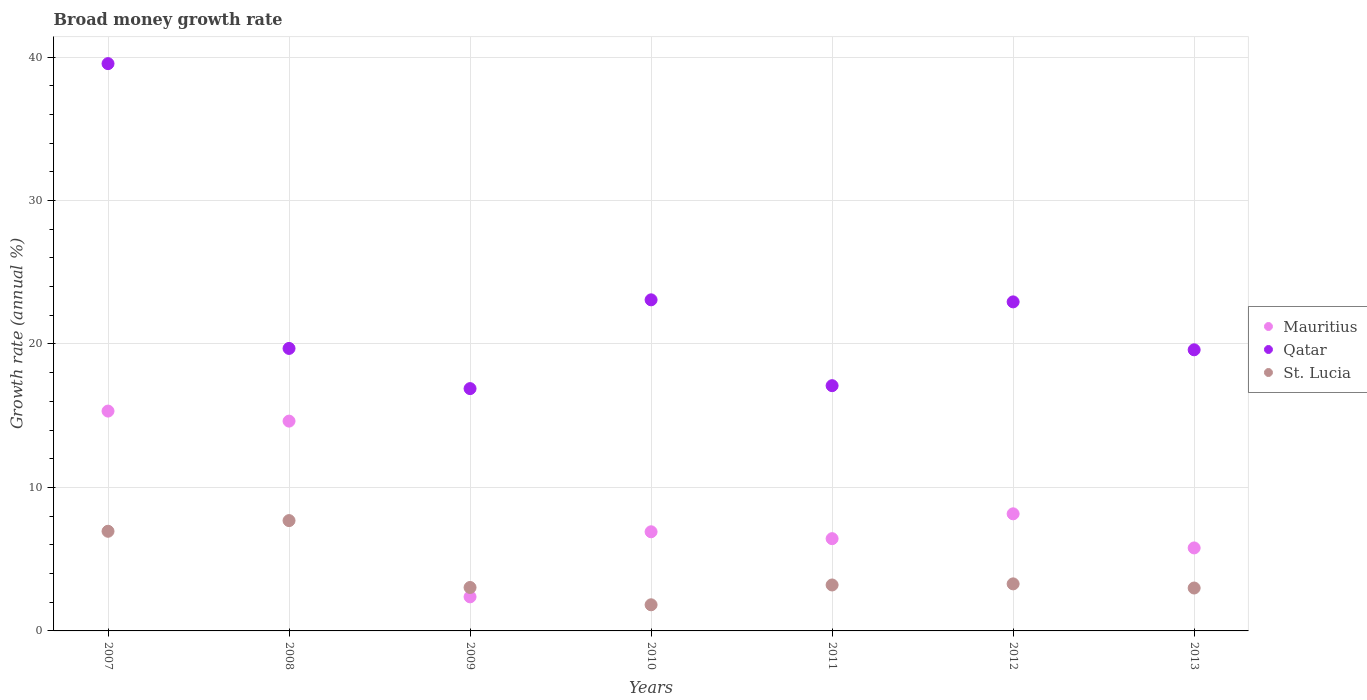What is the growth rate in Qatar in 2007?
Provide a short and direct response. 39.54. Across all years, what is the maximum growth rate in St. Lucia?
Offer a very short reply. 7.69. Across all years, what is the minimum growth rate in St. Lucia?
Your answer should be compact. 1.82. What is the total growth rate in St. Lucia in the graph?
Make the answer very short. 28.96. What is the difference between the growth rate in St. Lucia in 2009 and that in 2013?
Provide a short and direct response. 0.04. What is the difference between the growth rate in Mauritius in 2008 and the growth rate in Qatar in 2010?
Offer a terse response. -8.45. What is the average growth rate in Qatar per year?
Make the answer very short. 22.69. In the year 2010, what is the difference between the growth rate in St. Lucia and growth rate in Qatar?
Keep it short and to the point. -21.26. What is the ratio of the growth rate in Qatar in 2009 to that in 2010?
Your response must be concise. 0.73. Is the growth rate in St. Lucia in 2011 less than that in 2012?
Provide a succinct answer. Yes. Is the difference between the growth rate in St. Lucia in 2008 and 2013 greater than the difference between the growth rate in Qatar in 2008 and 2013?
Make the answer very short. Yes. What is the difference between the highest and the second highest growth rate in Qatar?
Give a very brief answer. 16.46. What is the difference between the highest and the lowest growth rate in Mauritius?
Offer a terse response. 12.95. In how many years, is the growth rate in Mauritius greater than the average growth rate in Mauritius taken over all years?
Your response must be concise. 2. Is the sum of the growth rate in Qatar in 2011 and 2012 greater than the maximum growth rate in St. Lucia across all years?
Provide a short and direct response. Yes. Is the growth rate in Qatar strictly greater than the growth rate in Mauritius over the years?
Offer a very short reply. Yes. Is the growth rate in St. Lucia strictly less than the growth rate in Qatar over the years?
Make the answer very short. Yes. How many dotlines are there?
Provide a succinct answer. 3. Are the values on the major ticks of Y-axis written in scientific E-notation?
Make the answer very short. No. Does the graph contain grids?
Your answer should be compact. Yes. Where does the legend appear in the graph?
Offer a terse response. Center right. What is the title of the graph?
Offer a terse response. Broad money growth rate. Does "Uzbekistan" appear as one of the legend labels in the graph?
Ensure brevity in your answer.  No. What is the label or title of the Y-axis?
Offer a very short reply. Growth rate (annual %). What is the Growth rate (annual %) of Mauritius in 2007?
Ensure brevity in your answer.  15.32. What is the Growth rate (annual %) in Qatar in 2007?
Provide a succinct answer. 39.54. What is the Growth rate (annual %) in St. Lucia in 2007?
Your answer should be very brief. 6.95. What is the Growth rate (annual %) of Mauritius in 2008?
Your answer should be compact. 14.62. What is the Growth rate (annual %) of Qatar in 2008?
Keep it short and to the point. 19.69. What is the Growth rate (annual %) in St. Lucia in 2008?
Make the answer very short. 7.69. What is the Growth rate (annual %) of Mauritius in 2009?
Keep it short and to the point. 2.37. What is the Growth rate (annual %) in Qatar in 2009?
Your answer should be compact. 16.89. What is the Growth rate (annual %) in St. Lucia in 2009?
Your answer should be very brief. 3.03. What is the Growth rate (annual %) of Mauritius in 2010?
Give a very brief answer. 6.91. What is the Growth rate (annual %) in Qatar in 2010?
Your answer should be very brief. 23.08. What is the Growth rate (annual %) in St. Lucia in 2010?
Give a very brief answer. 1.82. What is the Growth rate (annual %) in Mauritius in 2011?
Provide a succinct answer. 6.43. What is the Growth rate (annual %) of Qatar in 2011?
Your answer should be compact. 17.09. What is the Growth rate (annual %) of St. Lucia in 2011?
Ensure brevity in your answer.  3.2. What is the Growth rate (annual %) of Mauritius in 2012?
Your response must be concise. 8.16. What is the Growth rate (annual %) in Qatar in 2012?
Your answer should be compact. 22.93. What is the Growth rate (annual %) of St. Lucia in 2012?
Keep it short and to the point. 3.28. What is the Growth rate (annual %) in Mauritius in 2013?
Provide a succinct answer. 5.78. What is the Growth rate (annual %) of Qatar in 2013?
Provide a succinct answer. 19.59. What is the Growth rate (annual %) in St. Lucia in 2013?
Ensure brevity in your answer.  2.99. Across all years, what is the maximum Growth rate (annual %) of Mauritius?
Ensure brevity in your answer.  15.32. Across all years, what is the maximum Growth rate (annual %) in Qatar?
Keep it short and to the point. 39.54. Across all years, what is the maximum Growth rate (annual %) of St. Lucia?
Your answer should be very brief. 7.69. Across all years, what is the minimum Growth rate (annual %) in Mauritius?
Offer a very short reply. 2.37. Across all years, what is the minimum Growth rate (annual %) in Qatar?
Your answer should be compact. 16.89. Across all years, what is the minimum Growth rate (annual %) in St. Lucia?
Offer a very short reply. 1.82. What is the total Growth rate (annual %) in Mauritius in the graph?
Provide a succinct answer. 59.61. What is the total Growth rate (annual %) of Qatar in the graph?
Provide a succinct answer. 158.82. What is the total Growth rate (annual %) in St. Lucia in the graph?
Your answer should be compact. 28.96. What is the difference between the Growth rate (annual %) of Mauritius in 2007 and that in 2008?
Offer a terse response. 0.7. What is the difference between the Growth rate (annual %) of Qatar in 2007 and that in 2008?
Keep it short and to the point. 19.85. What is the difference between the Growth rate (annual %) of St. Lucia in 2007 and that in 2008?
Offer a terse response. -0.74. What is the difference between the Growth rate (annual %) in Mauritius in 2007 and that in 2009?
Make the answer very short. 12.95. What is the difference between the Growth rate (annual %) in Qatar in 2007 and that in 2009?
Your response must be concise. 22.65. What is the difference between the Growth rate (annual %) of St. Lucia in 2007 and that in 2009?
Provide a short and direct response. 3.92. What is the difference between the Growth rate (annual %) in Mauritius in 2007 and that in 2010?
Ensure brevity in your answer.  8.41. What is the difference between the Growth rate (annual %) in Qatar in 2007 and that in 2010?
Your answer should be compact. 16.46. What is the difference between the Growth rate (annual %) in St. Lucia in 2007 and that in 2010?
Make the answer very short. 5.12. What is the difference between the Growth rate (annual %) of Mauritius in 2007 and that in 2011?
Your response must be concise. 8.89. What is the difference between the Growth rate (annual %) in Qatar in 2007 and that in 2011?
Your response must be concise. 22.45. What is the difference between the Growth rate (annual %) of St. Lucia in 2007 and that in 2011?
Your response must be concise. 3.74. What is the difference between the Growth rate (annual %) in Mauritius in 2007 and that in 2012?
Provide a short and direct response. 7.16. What is the difference between the Growth rate (annual %) of Qatar in 2007 and that in 2012?
Offer a terse response. 16.61. What is the difference between the Growth rate (annual %) of St. Lucia in 2007 and that in 2012?
Give a very brief answer. 3.67. What is the difference between the Growth rate (annual %) of Mauritius in 2007 and that in 2013?
Offer a terse response. 9.54. What is the difference between the Growth rate (annual %) in Qatar in 2007 and that in 2013?
Make the answer very short. 19.95. What is the difference between the Growth rate (annual %) in St. Lucia in 2007 and that in 2013?
Keep it short and to the point. 3.95. What is the difference between the Growth rate (annual %) of Mauritius in 2008 and that in 2009?
Your response must be concise. 12.25. What is the difference between the Growth rate (annual %) of Qatar in 2008 and that in 2009?
Keep it short and to the point. 2.8. What is the difference between the Growth rate (annual %) in St. Lucia in 2008 and that in 2009?
Your response must be concise. 4.66. What is the difference between the Growth rate (annual %) in Mauritius in 2008 and that in 2010?
Your response must be concise. 7.71. What is the difference between the Growth rate (annual %) in Qatar in 2008 and that in 2010?
Offer a very short reply. -3.39. What is the difference between the Growth rate (annual %) in St. Lucia in 2008 and that in 2010?
Provide a short and direct response. 5.87. What is the difference between the Growth rate (annual %) in Mauritius in 2008 and that in 2011?
Provide a short and direct response. 8.19. What is the difference between the Growth rate (annual %) in Qatar in 2008 and that in 2011?
Offer a very short reply. 2.6. What is the difference between the Growth rate (annual %) of St. Lucia in 2008 and that in 2011?
Your answer should be very brief. 4.49. What is the difference between the Growth rate (annual %) of Mauritius in 2008 and that in 2012?
Provide a succinct answer. 6.46. What is the difference between the Growth rate (annual %) of Qatar in 2008 and that in 2012?
Offer a terse response. -3.24. What is the difference between the Growth rate (annual %) of St. Lucia in 2008 and that in 2012?
Ensure brevity in your answer.  4.41. What is the difference between the Growth rate (annual %) in Mauritius in 2008 and that in 2013?
Keep it short and to the point. 8.84. What is the difference between the Growth rate (annual %) of Qatar in 2008 and that in 2013?
Keep it short and to the point. 0.1. What is the difference between the Growth rate (annual %) of St. Lucia in 2008 and that in 2013?
Provide a succinct answer. 4.7. What is the difference between the Growth rate (annual %) in Mauritius in 2009 and that in 2010?
Your answer should be compact. -4.54. What is the difference between the Growth rate (annual %) in Qatar in 2009 and that in 2010?
Your answer should be compact. -6.19. What is the difference between the Growth rate (annual %) of St. Lucia in 2009 and that in 2010?
Provide a succinct answer. 1.21. What is the difference between the Growth rate (annual %) of Mauritius in 2009 and that in 2011?
Make the answer very short. -4.06. What is the difference between the Growth rate (annual %) of Qatar in 2009 and that in 2011?
Keep it short and to the point. -0.2. What is the difference between the Growth rate (annual %) in St. Lucia in 2009 and that in 2011?
Your answer should be compact. -0.17. What is the difference between the Growth rate (annual %) in Mauritius in 2009 and that in 2012?
Provide a short and direct response. -5.79. What is the difference between the Growth rate (annual %) in Qatar in 2009 and that in 2012?
Your response must be concise. -6.04. What is the difference between the Growth rate (annual %) in St. Lucia in 2009 and that in 2012?
Offer a very short reply. -0.25. What is the difference between the Growth rate (annual %) of Mauritius in 2009 and that in 2013?
Your response must be concise. -3.41. What is the difference between the Growth rate (annual %) in Qatar in 2009 and that in 2013?
Provide a succinct answer. -2.7. What is the difference between the Growth rate (annual %) of St. Lucia in 2009 and that in 2013?
Provide a succinct answer. 0.04. What is the difference between the Growth rate (annual %) in Mauritius in 2010 and that in 2011?
Make the answer very short. 0.48. What is the difference between the Growth rate (annual %) of Qatar in 2010 and that in 2011?
Offer a very short reply. 5.98. What is the difference between the Growth rate (annual %) of St. Lucia in 2010 and that in 2011?
Provide a succinct answer. -1.38. What is the difference between the Growth rate (annual %) in Mauritius in 2010 and that in 2012?
Your answer should be very brief. -1.25. What is the difference between the Growth rate (annual %) in Qatar in 2010 and that in 2012?
Your response must be concise. 0.14. What is the difference between the Growth rate (annual %) in St. Lucia in 2010 and that in 2012?
Offer a terse response. -1.46. What is the difference between the Growth rate (annual %) of Mauritius in 2010 and that in 2013?
Provide a succinct answer. 1.13. What is the difference between the Growth rate (annual %) of Qatar in 2010 and that in 2013?
Ensure brevity in your answer.  3.48. What is the difference between the Growth rate (annual %) in St. Lucia in 2010 and that in 2013?
Provide a succinct answer. -1.17. What is the difference between the Growth rate (annual %) of Mauritius in 2011 and that in 2012?
Your response must be concise. -1.73. What is the difference between the Growth rate (annual %) of Qatar in 2011 and that in 2012?
Keep it short and to the point. -5.84. What is the difference between the Growth rate (annual %) of St. Lucia in 2011 and that in 2012?
Your answer should be very brief. -0.08. What is the difference between the Growth rate (annual %) of Mauritius in 2011 and that in 2013?
Give a very brief answer. 0.65. What is the difference between the Growth rate (annual %) in Qatar in 2011 and that in 2013?
Provide a succinct answer. -2.5. What is the difference between the Growth rate (annual %) in St. Lucia in 2011 and that in 2013?
Your response must be concise. 0.21. What is the difference between the Growth rate (annual %) in Mauritius in 2012 and that in 2013?
Keep it short and to the point. 2.38. What is the difference between the Growth rate (annual %) of Qatar in 2012 and that in 2013?
Keep it short and to the point. 3.34. What is the difference between the Growth rate (annual %) in St. Lucia in 2012 and that in 2013?
Make the answer very short. 0.29. What is the difference between the Growth rate (annual %) of Mauritius in 2007 and the Growth rate (annual %) of Qatar in 2008?
Your response must be concise. -4.37. What is the difference between the Growth rate (annual %) in Mauritius in 2007 and the Growth rate (annual %) in St. Lucia in 2008?
Provide a short and direct response. 7.63. What is the difference between the Growth rate (annual %) in Qatar in 2007 and the Growth rate (annual %) in St. Lucia in 2008?
Your response must be concise. 31.85. What is the difference between the Growth rate (annual %) in Mauritius in 2007 and the Growth rate (annual %) in Qatar in 2009?
Give a very brief answer. -1.57. What is the difference between the Growth rate (annual %) of Mauritius in 2007 and the Growth rate (annual %) of St. Lucia in 2009?
Provide a short and direct response. 12.29. What is the difference between the Growth rate (annual %) of Qatar in 2007 and the Growth rate (annual %) of St. Lucia in 2009?
Make the answer very short. 36.51. What is the difference between the Growth rate (annual %) of Mauritius in 2007 and the Growth rate (annual %) of Qatar in 2010?
Your response must be concise. -7.75. What is the difference between the Growth rate (annual %) in Mauritius in 2007 and the Growth rate (annual %) in St. Lucia in 2010?
Your answer should be compact. 13.5. What is the difference between the Growth rate (annual %) of Qatar in 2007 and the Growth rate (annual %) of St. Lucia in 2010?
Make the answer very short. 37.72. What is the difference between the Growth rate (annual %) in Mauritius in 2007 and the Growth rate (annual %) in Qatar in 2011?
Keep it short and to the point. -1.77. What is the difference between the Growth rate (annual %) in Mauritius in 2007 and the Growth rate (annual %) in St. Lucia in 2011?
Offer a very short reply. 12.12. What is the difference between the Growth rate (annual %) in Qatar in 2007 and the Growth rate (annual %) in St. Lucia in 2011?
Offer a terse response. 36.34. What is the difference between the Growth rate (annual %) in Mauritius in 2007 and the Growth rate (annual %) in Qatar in 2012?
Give a very brief answer. -7.61. What is the difference between the Growth rate (annual %) of Mauritius in 2007 and the Growth rate (annual %) of St. Lucia in 2012?
Your answer should be very brief. 12.04. What is the difference between the Growth rate (annual %) of Qatar in 2007 and the Growth rate (annual %) of St. Lucia in 2012?
Give a very brief answer. 36.26. What is the difference between the Growth rate (annual %) of Mauritius in 2007 and the Growth rate (annual %) of Qatar in 2013?
Offer a terse response. -4.27. What is the difference between the Growth rate (annual %) in Mauritius in 2007 and the Growth rate (annual %) in St. Lucia in 2013?
Provide a short and direct response. 12.33. What is the difference between the Growth rate (annual %) of Qatar in 2007 and the Growth rate (annual %) of St. Lucia in 2013?
Your response must be concise. 36.55. What is the difference between the Growth rate (annual %) in Mauritius in 2008 and the Growth rate (annual %) in Qatar in 2009?
Give a very brief answer. -2.27. What is the difference between the Growth rate (annual %) in Mauritius in 2008 and the Growth rate (annual %) in St. Lucia in 2009?
Provide a succinct answer. 11.6. What is the difference between the Growth rate (annual %) of Qatar in 2008 and the Growth rate (annual %) of St. Lucia in 2009?
Provide a succinct answer. 16.66. What is the difference between the Growth rate (annual %) in Mauritius in 2008 and the Growth rate (annual %) in Qatar in 2010?
Offer a very short reply. -8.45. What is the difference between the Growth rate (annual %) in Mauritius in 2008 and the Growth rate (annual %) in St. Lucia in 2010?
Ensure brevity in your answer.  12.8. What is the difference between the Growth rate (annual %) in Qatar in 2008 and the Growth rate (annual %) in St. Lucia in 2010?
Offer a terse response. 17.87. What is the difference between the Growth rate (annual %) of Mauritius in 2008 and the Growth rate (annual %) of Qatar in 2011?
Give a very brief answer. -2.47. What is the difference between the Growth rate (annual %) in Mauritius in 2008 and the Growth rate (annual %) in St. Lucia in 2011?
Provide a succinct answer. 11.42. What is the difference between the Growth rate (annual %) in Qatar in 2008 and the Growth rate (annual %) in St. Lucia in 2011?
Offer a terse response. 16.49. What is the difference between the Growth rate (annual %) of Mauritius in 2008 and the Growth rate (annual %) of Qatar in 2012?
Provide a succinct answer. -8.31. What is the difference between the Growth rate (annual %) of Mauritius in 2008 and the Growth rate (annual %) of St. Lucia in 2012?
Your answer should be compact. 11.34. What is the difference between the Growth rate (annual %) of Qatar in 2008 and the Growth rate (annual %) of St. Lucia in 2012?
Your response must be concise. 16.41. What is the difference between the Growth rate (annual %) in Mauritius in 2008 and the Growth rate (annual %) in Qatar in 2013?
Your answer should be compact. -4.97. What is the difference between the Growth rate (annual %) of Mauritius in 2008 and the Growth rate (annual %) of St. Lucia in 2013?
Offer a terse response. 11.63. What is the difference between the Growth rate (annual %) in Qatar in 2008 and the Growth rate (annual %) in St. Lucia in 2013?
Your response must be concise. 16.7. What is the difference between the Growth rate (annual %) of Mauritius in 2009 and the Growth rate (annual %) of Qatar in 2010?
Offer a terse response. -20.7. What is the difference between the Growth rate (annual %) in Mauritius in 2009 and the Growth rate (annual %) in St. Lucia in 2010?
Offer a terse response. 0.55. What is the difference between the Growth rate (annual %) of Qatar in 2009 and the Growth rate (annual %) of St. Lucia in 2010?
Make the answer very short. 15.07. What is the difference between the Growth rate (annual %) in Mauritius in 2009 and the Growth rate (annual %) in Qatar in 2011?
Make the answer very short. -14.72. What is the difference between the Growth rate (annual %) of Mauritius in 2009 and the Growth rate (annual %) of St. Lucia in 2011?
Ensure brevity in your answer.  -0.83. What is the difference between the Growth rate (annual %) in Qatar in 2009 and the Growth rate (annual %) in St. Lucia in 2011?
Offer a terse response. 13.69. What is the difference between the Growth rate (annual %) of Mauritius in 2009 and the Growth rate (annual %) of Qatar in 2012?
Your answer should be compact. -20.56. What is the difference between the Growth rate (annual %) of Mauritius in 2009 and the Growth rate (annual %) of St. Lucia in 2012?
Give a very brief answer. -0.91. What is the difference between the Growth rate (annual %) in Qatar in 2009 and the Growth rate (annual %) in St. Lucia in 2012?
Ensure brevity in your answer.  13.61. What is the difference between the Growth rate (annual %) of Mauritius in 2009 and the Growth rate (annual %) of Qatar in 2013?
Provide a succinct answer. -17.22. What is the difference between the Growth rate (annual %) of Mauritius in 2009 and the Growth rate (annual %) of St. Lucia in 2013?
Your answer should be compact. -0.62. What is the difference between the Growth rate (annual %) in Qatar in 2009 and the Growth rate (annual %) in St. Lucia in 2013?
Offer a very short reply. 13.9. What is the difference between the Growth rate (annual %) of Mauritius in 2010 and the Growth rate (annual %) of Qatar in 2011?
Your answer should be compact. -10.18. What is the difference between the Growth rate (annual %) in Mauritius in 2010 and the Growth rate (annual %) in St. Lucia in 2011?
Your answer should be compact. 3.71. What is the difference between the Growth rate (annual %) in Qatar in 2010 and the Growth rate (annual %) in St. Lucia in 2011?
Your response must be concise. 19.87. What is the difference between the Growth rate (annual %) in Mauritius in 2010 and the Growth rate (annual %) in Qatar in 2012?
Provide a short and direct response. -16.02. What is the difference between the Growth rate (annual %) in Mauritius in 2010 and the Growth rate (annual %) in St. Lucia in 2012?
Provide a short and direct response. 3.63. What is the difference between the Growth rate (annual %) in Qatar in 2010 and the Growth rate (annual %) in St. Lucia in 2012?
Offer a very short reply. 19.8. What is the difference between the Growth rate (annual %) in Mauritius in 2010 and the Growth rate (annual %) in Qatar in 2013?
Keep it short and to the point. -12.68. What is the difference between the Growth rate (annual %) of Mauritius in 2010 and the Growth rate (annual %) of St. Lucia in 2013?
Your answer should be compact. 3.92. What is the difference between the Growth rate (annual %) in Qatar in 2010 and the Growth rate (annual %) in St. Lucia in 2013?
Give a very brief answer. 20.09. What is the difference between the Growth rate (annual %) of Mauritius in 2011 and the Growth rate (annual %) of Qatar in 2012?
Provide a short and direct response. -16.5. What is the difference between the Growth rate (annual %) in Mauritius in 2011 and the Growth rate (annual %) in St. Lucia in 2012?
Make the answer very short. 3.15. What is the difference between the Growth rate (annual %) of Qatar in 2011 and the Growth rate (annual %) of St. Lucia in 2012?
Offer a very short reply. 13.81. What is the difference between the Growth rate (annual %) of Mauritius in 2011 and the Growth rate (annual %) of Qatar in 2013?
Provide a succinct answer. -13.16. What is the difference between the Growth rate (annual %) of Mauritius in 2011 and the Growth rate (annual %) of St. Lucia in 2013?
Your answer should be compact. 3.44. What is the difference between the Growth rate (annual %) of Qatar in 2011 and the Growth rate (annual %) of St. Lucia in 2013?
Make the answer very short. 14.1. What is the difference between the Growth rate (annual %) in Mauritius in 2012 and the Growth rate (annual %) in Qatar in 2013?
Ensure brevity in your answer.  -11.43. What is the difference between the Growth rate (annual %) in Mauritius in 2012 and the Growth rate (annual %) in St. Lucia in 2013?
Your answer should be very brief. 5.17. What is the difference between the Growth rate (annual %) of Qatar in 2012 and the Growth rate (annual %) of St. Lucia in 2013?
Your answer should be very brief. 19.94. What is the average Growth rate (annual %) of Mauritius per year?
Provide a succinct answer. 8.52. What is the average Growth rate (annual %) of Qatar per year?
Make the answer very short. 22.69. What is the average Growth rate (annual %) of St. Lucia per year?
Your answer should be compact. 4.14. In the year 2007, what is the difference between the Growth rate (annual %) of Mauritius and Growth rate (annual %) of Qatar?
Offer a very short reply. -24.22. In the year 2007, what is the difference between the Growth rate (annual %) in Mauritius and Growth rate (annual %) in St. Lucia?
Keep it short and to the point. 8.38. In the year 2007, what is the difference between the Growth rate (annual %) in Qatar and Growth rate (annual %) in St. Lucia?
Your response must be concise. 32.59. In the year 2008, what is the difference between the Growth rate (annual %) in Mauritius and Growth rate (annual %) in Qatar?
Give a very brief answer. -5.07. In the year 2008, what is the difference between the Growth rate (annual %) of Mauritius and Growth rate (annual %) of St. Lucia?
Your answer should be very brief. 6.93. In the year 2008, what is the difference between the Growth rate (annual %) in Qatar and Growth rate (annual %) in St. Lucia?
Your answer should be compact. 12. In the year 2009, what is the difference between the Growth rate (annual %) in Mauritius and Growth rate (annual %) in Qatar?
Your answer should be very brief. -14.51. In the year 2009, what is the difference between the Growth rate (annual %) in Mauritius and Growth rate (annual %) in St. Lucia?
Make the answer very short. -0.65. In the year 2009, what is the difference between the Growth rate (annual %) in Qatar and Growth rate (annual %) in St. Lucia?
Make the answer very short. 13.86. In the year 2010, what is the difference between the Growth rate (annual %) of Mauritius and Growth rate (annual %) of Qatar?
Offer a very short reply. -16.17. In the year 2010, what is the difference between the Growth rate (annual %) of Mauritius and Growth rate (annual %) of St. Lucia?
Ensure brevity in your answer.  5.09. In the year 2010, what is the difference between the Growth rate (annual %) of Qatar and Growth rate (annual %) of St. Lucia?
Ensure brevity in your answer.  21.26. In the year 2011, what is the difference between the Growth rate (annual %) of Mauritius and Growth rate (annual %) of Qatar?
Offer a terse response. -10.66. In the year 2011, what is the difference between the Growth rate (annual %) in Mauritius and Growth rate (annual %) in St. Lucia?
Give a very brief answer. 3.23. In the year 2011, what is the difference between the Growth rate (annual %) of Qatar and Growth rate (annual %) of St. Lucia?
Offer a very short reply. 13.89. In the year 2012, what is the difference between the Growth rate (annual %) of Mauritius and Growth rate (annual %) of Qatar?
Ensure brevity in your answer.  -14.77. In the year 2012, what is the difference between the Growth rate (annual %) in Mauritius and Growth rate (annual %) in St. Lucia?
Offer a very short reply. 4.88. In the year 2012, what is the difference between the Growth rate (annual %) in Qatar and Growth rate (annual %) in St. Lucia?
Give a very brief answer. 19.65. In the year 2013, what is the difference between the Growth rate (annual %) in Mauritius and Growth rate (annual %) in Qatar?
Offer a very short reply. -13.81. In the year 2013, what is the difference between the Growth rate (annual %) in Mauritius and Growth rate (annual %) in St. Lucia?
Give a very brief answer. 2.79. In the year 2013, what is the difference between the Growth rate (annual %) of Qatar and Growth rate (annual %) of St. Lucia?
Give a very brief answer. 16.6. What is the ratio of the Growth rate (annual %) of Mauritius in 2007 to that in 2008?
Make the answer very short. 1.05. What is the ratio of the Growth rate (annual %) of Qatar in 2007 to that in 2008?
Your response must be concise. 2.01. What is the ratio of the Growth rate (annual %) of St. Lucia in 2007 to that in 2008?
Your response must be concise. 0.9. What is the ratio of the Growth rate (annual %) of Mauritius in 2007 to that in 2009?
Ensure brevity in your answer.  6.45. What is the ratio of the Growth rate (annual %) of Qatar in 2007 to that in 2009?
Ensure brevity in your answer.  2.34. What is the ratio of the Growth rate (annual %) of St. Lucia in 2007 to that in 2009?
Provide a short and direct response. 2.29. What is the ratio of the Growth rate (annual %) of Mauritius in 2007 to that in 2010?
Your answer should be very brief. 2.22. What is the ratio of the Growth rate (annual %) in Qatar in 2007 to that in 2010?
Ensure brevity in your answer.  1.71. What is the ratio of the Growth rate (annual %) in St. Lucia in 2007 to that in 2010?
Keep it short and to the point. 3.81. What is the ratio of the Growth rate (annual %) of Mauritius in 2007 to that in 2011?
Provide a short and direct response. 2.38. What is the ratio of the Growth rate (annual %) in Qatar in 2007 to that in 2011?
Your answer should be compact. 2.31. What is the ratio of the Growth rate (annual %) of St. Lucia in 2007 to that in 2011?
Offer a terse response. 2.17. What is the ratio of the Growth rate (annual %) of Mauritius in 2007 to that in 2012?
Provide a succinct answer. 1.88. What is the ratio of the Growth rate (annual %) in Qatar in 2007 to that in 2012?
Your response must be concise. 1.72. What is the ratio of the Growth rate (annual %) of St. Lucia in 2007 to that in 2012?
Your answer should be compact. 2.12. What is the ratio of the Growth rate (annual %) of Mauritius in 2007 to that in 2013?
Give a very brief answer. 2.65. What is the ratio of the Growth rate (annual %) of Qatar in 2007 to that in 2013?
Offer a terse response. 2.02. What is the ratio of the Growth rate (annual %) in St. Lucia in 2007 to that in 2013?
Your answer should be very brief. 2.32. What is the ratio of the Growth rate (annual %) in Mauritius in 2008 to that in 2009?
Offer a terse response. 6.16. What is the ratio of the Growth rate (annual %) in Qatar in 2008 to that in 2009?
Ensure brevity in your answer.  1.17. What is the ratio of the Growth rate (annual %) in St. Lucia in 2008 to that in 2009?
Keep it short and to the point. 2.54. What is the ratio of the Growth rate (annual %) of Mauritius in 2008 to that in 2010?
Offer a terse response. 2.12. What is the ratio of the Growth rate (annual %) in Qatar in 2008 to that in 2010?
Make the answer very short. 0.85. What is the ratio of the Growth rate (annual %) in St. Lucia in 2008 to that in 2010?
Give a very brief answer. 4.22. What is the ratio of the Growth rate (annual %) of Mauritius in 2008 to that in 2011?
Offer a very short reply. 2.27. What is the ratio of the Growth rate (annual %) of Qatar in 2008 to that in 2011?
Give a very brief answer. 1.15. What is the ratio of the Growth rate (annual %) of St. Lucia in 2008 to that in 2011?
Provide a short and direct response. 2.4. What is the ratio of the Growth rate (annual %) of Mauritius in 2008 to that in 2012?
Your response must be concise. 1.79. What is the ratio of the Growth rate (annual %) in Qatar in 2008 to that in 2012?
Offer a terse response. 0.86. What is the ratio of the Growth rate (annual %) in St. Lucia in 2008 to that in 2012?
Your answer should be very brief. 2.34. What is the ratio of the Growth rate (annual %) of Mauritius in 2008 to that in 2013?
Keep it short and to the point. 2.53. What is the ratio of the Growth rate (annual %) of St. Lucia in 2008 to that in 2013?
Ensure brevity in your answer.  2.57. What is the ratio of the Growth rate (annual %) in Mauritius in 2009 to that in 2010?
Make the answer very short. 0.34. What is the ratio of the Growth rate (annual %) of Qatar in 2009 to that in 2010?
Keep it short and to the point. 0.73. What is the ratio of the Growth rate (annual %) in St. Lucia in 2009 to that in 2010?
Provide a short and direct response. 1.66. What is the ratio of the Growth rate (annual %) of Mauritius in 2009 to that in 2011?
Your answer should be very brief. 0.37. What is the ratio of the Growth rate (annual %) of St. Lucia in 2009 to that in 2011?
Give a very brief answer. 0.95. What is the ratio of the Growth rate (annual %) in Mauritius in 2009 to that in 2012?
Give a very brief answer. 0.29. What is the ratio of the Growth rate (annual %) in Qatar in 2009 to that in 2012?
Provide a short and direct response. 0.74. What is the ratio of the Growth rate (annual %) in St. Lucia in 2009 to that in 2012?
Offer a very short reply. 0.92. What is the ratio of the Growth rate (annual %) in Mauritius in 2009 to that in 2013?
Your answer should be compact. 0.41. What is the ratio of the Growth rate (annual %) in Qatar in 2009 to that in 2013?
Your answer should be compact. 0.86. What is the ratio of the Growth rate (annual %) of St. Lucia in 2009 to that in 2013?
Your answer should be compact. 1.01. What is the ratio of the Growth rate (annual %) of Mauritius in 2010 to that in 2011?
Make the answer very short. 1.07. What is the ratio of the Growth rate (annual %) in Qatar in 2010 to that in 2011?
Ensure brevity in your answer.  1.35. What is the ratio of the Growth rate (annual %) of St. Lucia in 2010 to that in 2011?
Your answer should be very brief. 0.57. What is the ratio of the Growth rate (annual %) of Mauritius in 2010 to that in 2012?
Provide a short and direct response. 0.85. What is the ratio of the Growth rate (annual %) in Qatar in 2010 to that in 2012?
Your answer should be compact. 1.01. What is the ratio of the Growth rate (annual %) of St. Lucia in 2010 to that in 2012?
Offer a very short reply. 0.56. What is the ratio of the Growth rate (annual %) in Mauritius in 2010 to that in 2013?
Your answer should be very brief. 1.19. What is the ratio of the Growth rate (annual %) in Qatar in 2010 to that in 2013?
Make the answer very short. 1.18. What is the ratio of the Growth rate (annual %) of St. Lucia in 2010 to that in 2013?
Your response must be concise. 0.61. What is the ratio of the Growth rate (annual %) of Mauritius in 2011 to that in 2012?
Provide a succinct answer. 0.79. What is the ratio of the Growth rate (annual %) of Qatar in 2011 to that in 2012?
Make the answer very short. 0.75. What is the ratio of the Growth rate (annual %) of St. Lucia in 2011 to that in 2012?
Your answer should be very brief. 0.98. What is the ratio of the Growth rate (annual %) in Mauritius in 2011 to that in 2013?
Offer a very short reply. 1.11. What is the ratio of the Growth rate (annual %) in Qatar in 2011 to that in 2013?
Offer a terse response. 0.87. What is the ratio of the Growth rate (annual %) in St. Lucia in 2011 to that in 2013?
Offer a terse response. 1.07. What is the ratio of the Growth rate (annual %) in Mauritius in 2012 to that in 2013?
Make the answer very short. 1.41. What is the ratio of the Growth rate (annual %) in Qatar in 2012 to that in 2013?
Your response must be concise. 1.17. What is the ratio of the Growth rate (annual %) in St. Lucia in 2012 to that in 2013?
Provide a succinct answer. 1.1. What is the difference between the highest and the second highest Growth rate (annual %) of Mauritius?
Give a very brief answer. 0.7. What is the difference between the highest and the second highest Growth rate (annual %) in Qatar?
Your answer should be compact. 16.46. What is the difference between the highest and the second highest Growth rate (annual %) in St. Lucia?
Your answer should be very brief. 0.74. What is the difference between the highest and the lowest Growth rate (annual %) in Mauritius?
Keep it short and to the point. 12.95. What is the difference between the highest and the lowest Growth rate (annual %) of Qatar?
Your answer should be very brief. 22.65. What is the difference between the highest and the lowest Growth rate (annual %) in St. Lucia?
Keep it short and to the point. 5.87. 